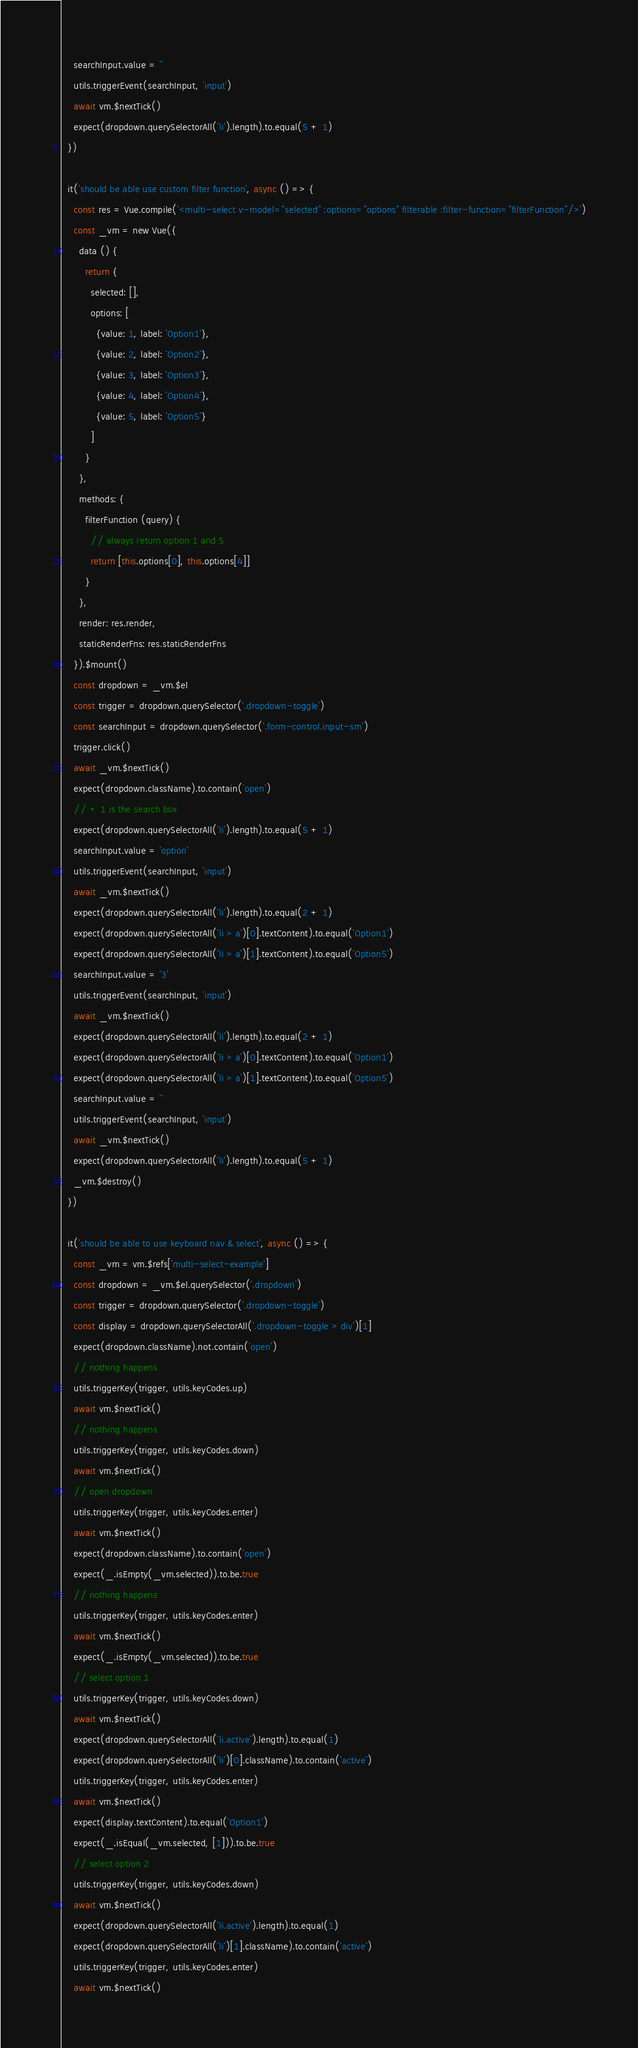Convert code to text. <code><loc_0><loc_0><loc_500><loc_500><_JavaScript_>    searchInput.value = ''
    utils.triggerEvent(searchInput, 'input')
    await vm.$nextTick()
    expect(dropdown.querySelectorAll('li').length).to.equal(5 + 1)
  })

  it('should be able use custom filter function', async () => {
    const res = Vue.compile('<multi-select v-model="selected" :options="options" filterable :filter-function="filterFunction"/>')
    const _vm = new Vue({
      data () {
        return {
          selected: [],
          options: [
            {value: 1, label: 'Option1'},
            {value: 2, label: 'Option2'},
            {value: 3, label: 'Option3'},
            {value: 4, label: 'Option4'},
            {value: 5, label: 'Option5'}
          ]
        }
      },
      methods: {
        filterFunction (query) {
          // always return option 1 and 5
          return [this.options[0], this.options[4]]
        }
      },
      render: res.render,
      staticRenderFns: res.staticRenderFns
    }).$mount()
    const dropdown = _vm.$el
    const trigger = dropdown.querySelector('.dropdown-toggle')
    const searchInput = dropdown.querySelector('.form-control.input-sm')
    trigger.click()
    await _vm.$nextTick()
    expect(dropdown.className).to.contain('open')
    // + 1 is the search box
    expect(dropdown.querySelectorAll('li').length).to.equal(5 + 1)
    searchInput.value = 'option'
    utils.triggerEvent(searchInput, 'input')
    await _vm.$nextTick()
    expect(dropdown.querySelectorAll('li').length).to.equal(2 + 1)
    expect(dropdown.querySelectorAll('li > a')[0].textContent).to.equal('Option1')
    expect(dropdown.querySelectorAll('li > a')[1].textContent).to.equal('Option5')
    searchInput.value = '3'
    utils.triggerEvent(searchInput, 'input')
    await _vm.$nextTick()
    expect(dropdown.querySelectorAll('li').length).to.equal(2 + 1)
    expect(dropdown.querySelectorAll('li > a')[0].textContent).to.equal('Option1')
    expect(dropdown.querySelectorAll('li > a')[1].textContent).to.equal('Option5')
    searchInput.value = ''
    utils.triggerEvent(searchInput, 'input')
    await _vm.$nextTick()
    expect(dropdown.querySelectorAll('li').length).to.equal(5 + 1)
    _vm.$destroy()
  })

  it('should be able to use keyboard nav & select', async () => {
    const _vm = vm.$refs['multi-select-example']
    const dropdown = _vm.$el.querySelector('.dropdown')
    const trigger = dropdown.querySelector('.dropdown-toggle')
    const display = dropdown.querySelectorAll('.dropdown-toggle > div')[1]
    expect(dropdown.className).not.contain('open')
    // nothing happens
    utils.triggerKey(trigger, utils.keyCodes.up)
    await vm.$nextTick()
    // nothing happens
    utils.triggerKey(trigger, utils.keyCodes.down)
    await vm.$nextTick()
    // open dropdown
    utils.triggerKey(trigger, utils.keyCodes.enter)
    await vm.$nextTick()
    expect(dropdown.className).to.contain('open')
    expect(_.isEmpty(_vm.selected)).to.be.true
    // nothing happens
    utils.triggerKey(trigger, utils.keyCodes.enter)
    await vm.$nextTick()
    expect(_.isEmpty(_vm.selected)).to.be.true
    // select option 1
    utils.triggerKey(trigger, utils.keyCodes.down)
    await vm.$nextTick()
    expect(dropdown.querySelectorAll('li.active').length).to.equal(1)
    expect(dropdown.querySelectorAll('li')[0].className).to.contain('active')
    utils.triggerKey(trigger, utils.keyCodes.enter)
    await vm.$nextTick()
    expect(display.textContent).to.equal('Option1')
    expect(_.isEqual(_vm.selected, [1])).to.be.true
    // select option 2
    utils.triggerKey(trigger, utils.keyCodes.down)
    await vm.$nextTick()
    expect(dropdown.querySelectorAll('li.active').length).to.equal(1)
    expect(dropdown.querySelectorAll('li')[1].className).to.contain('active')
    utils.triggerKey(trigger, utils.keyCodes.enter)
    await vm.$nextTick()</code> 